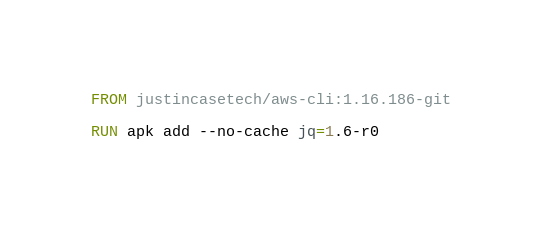Convert code to text. <code><loc_0><loc_0><loc_500><loc_500><_Dockerfile_>FROM justincasetech/aws-cli:1.16.186-git

RUN apk add --no-cache jq=1.6-r0
</code> 